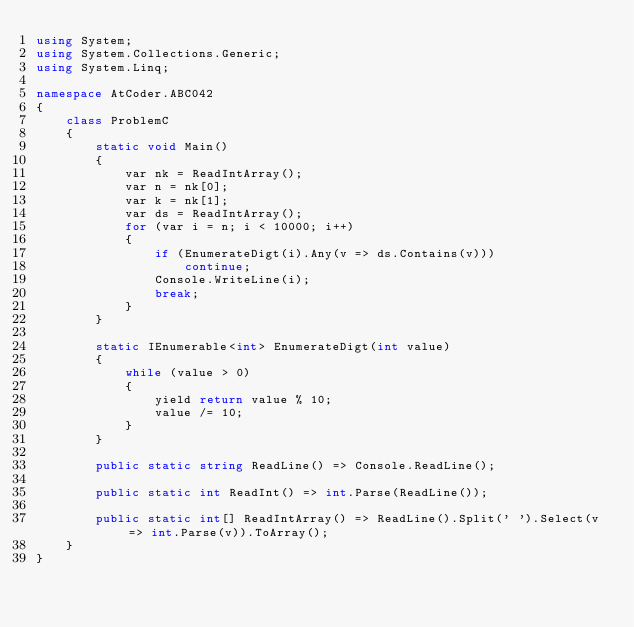Convert code to text. <code><loc_0><loc_0><loc_500><loc_500><_C#_>using System;
using System.Collections.Generic;
using System.Linq;

namespace AtCoder.ABC042
{
    class ProblemC
    {
        static void Main()
        {
            var nk = ReadIntArray();
            var n = nk[0];
            var k = nk[1];
            var ds = ReadIntArray();
            for (var i = n; i < 10000; i++)
            {
                if (EnumerateDigt(i).Any(v => ds.Contains(v)))
                    continue;
                Console.WriteLine(i);
                break;
            }
        }

        static IEnumerable<int> EnumerateDigt(int value)
        {
            while (value > 0)
            {
                yield return value % 10;
                value /= 10;
            }
        }

        public static string ReadLine() => Console.ReadLine();

        public static int ReadInt() => int.Parse(ReadLine());

        public static int[] ReadIntArray() => ReadLine().Split(' ').Select(v => int.Parse(v)).ToArray();
    }
}
</code> 